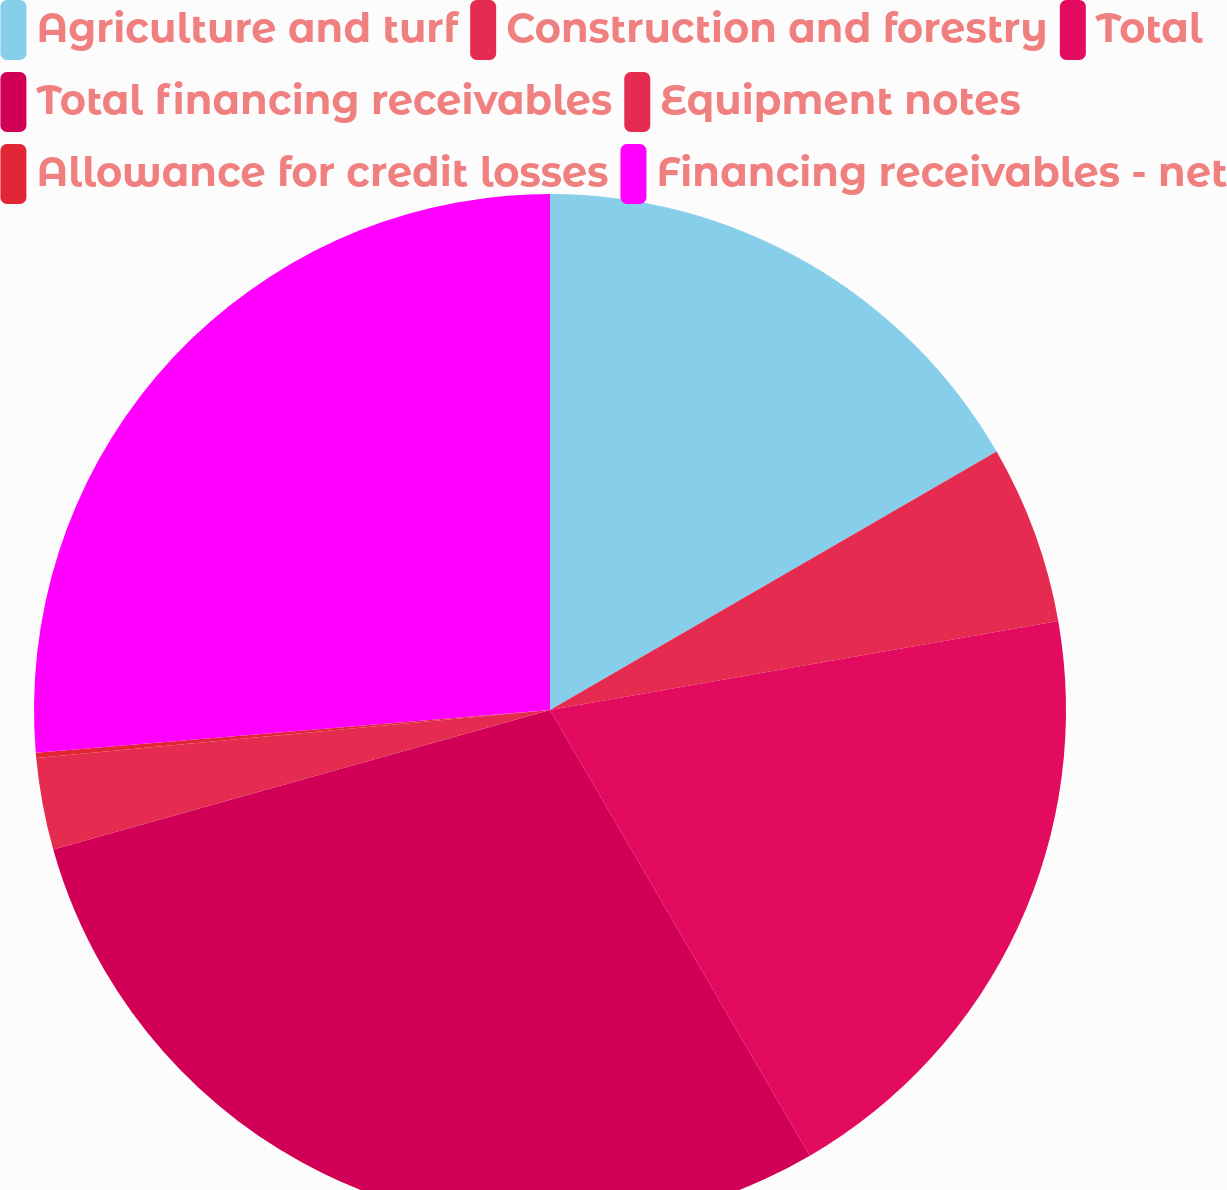<chart> <loc_0><loc_0><loc_500><loc_500><pie_chart><fcel>Agriculture and turf<fcel>Construction and forestry<fcel>Total<fcel>Total financing receivables<fcel>Equipment notes<fcel>Allowance for credit losses<fcel>Financing receivables - net<nl><fcel>16.65%<fcel>5.59%<fcel>19.36%<fcel>29.04%<fcel>2.88%<fcel>0.16%<fcel>26.32%<nl></chart> 